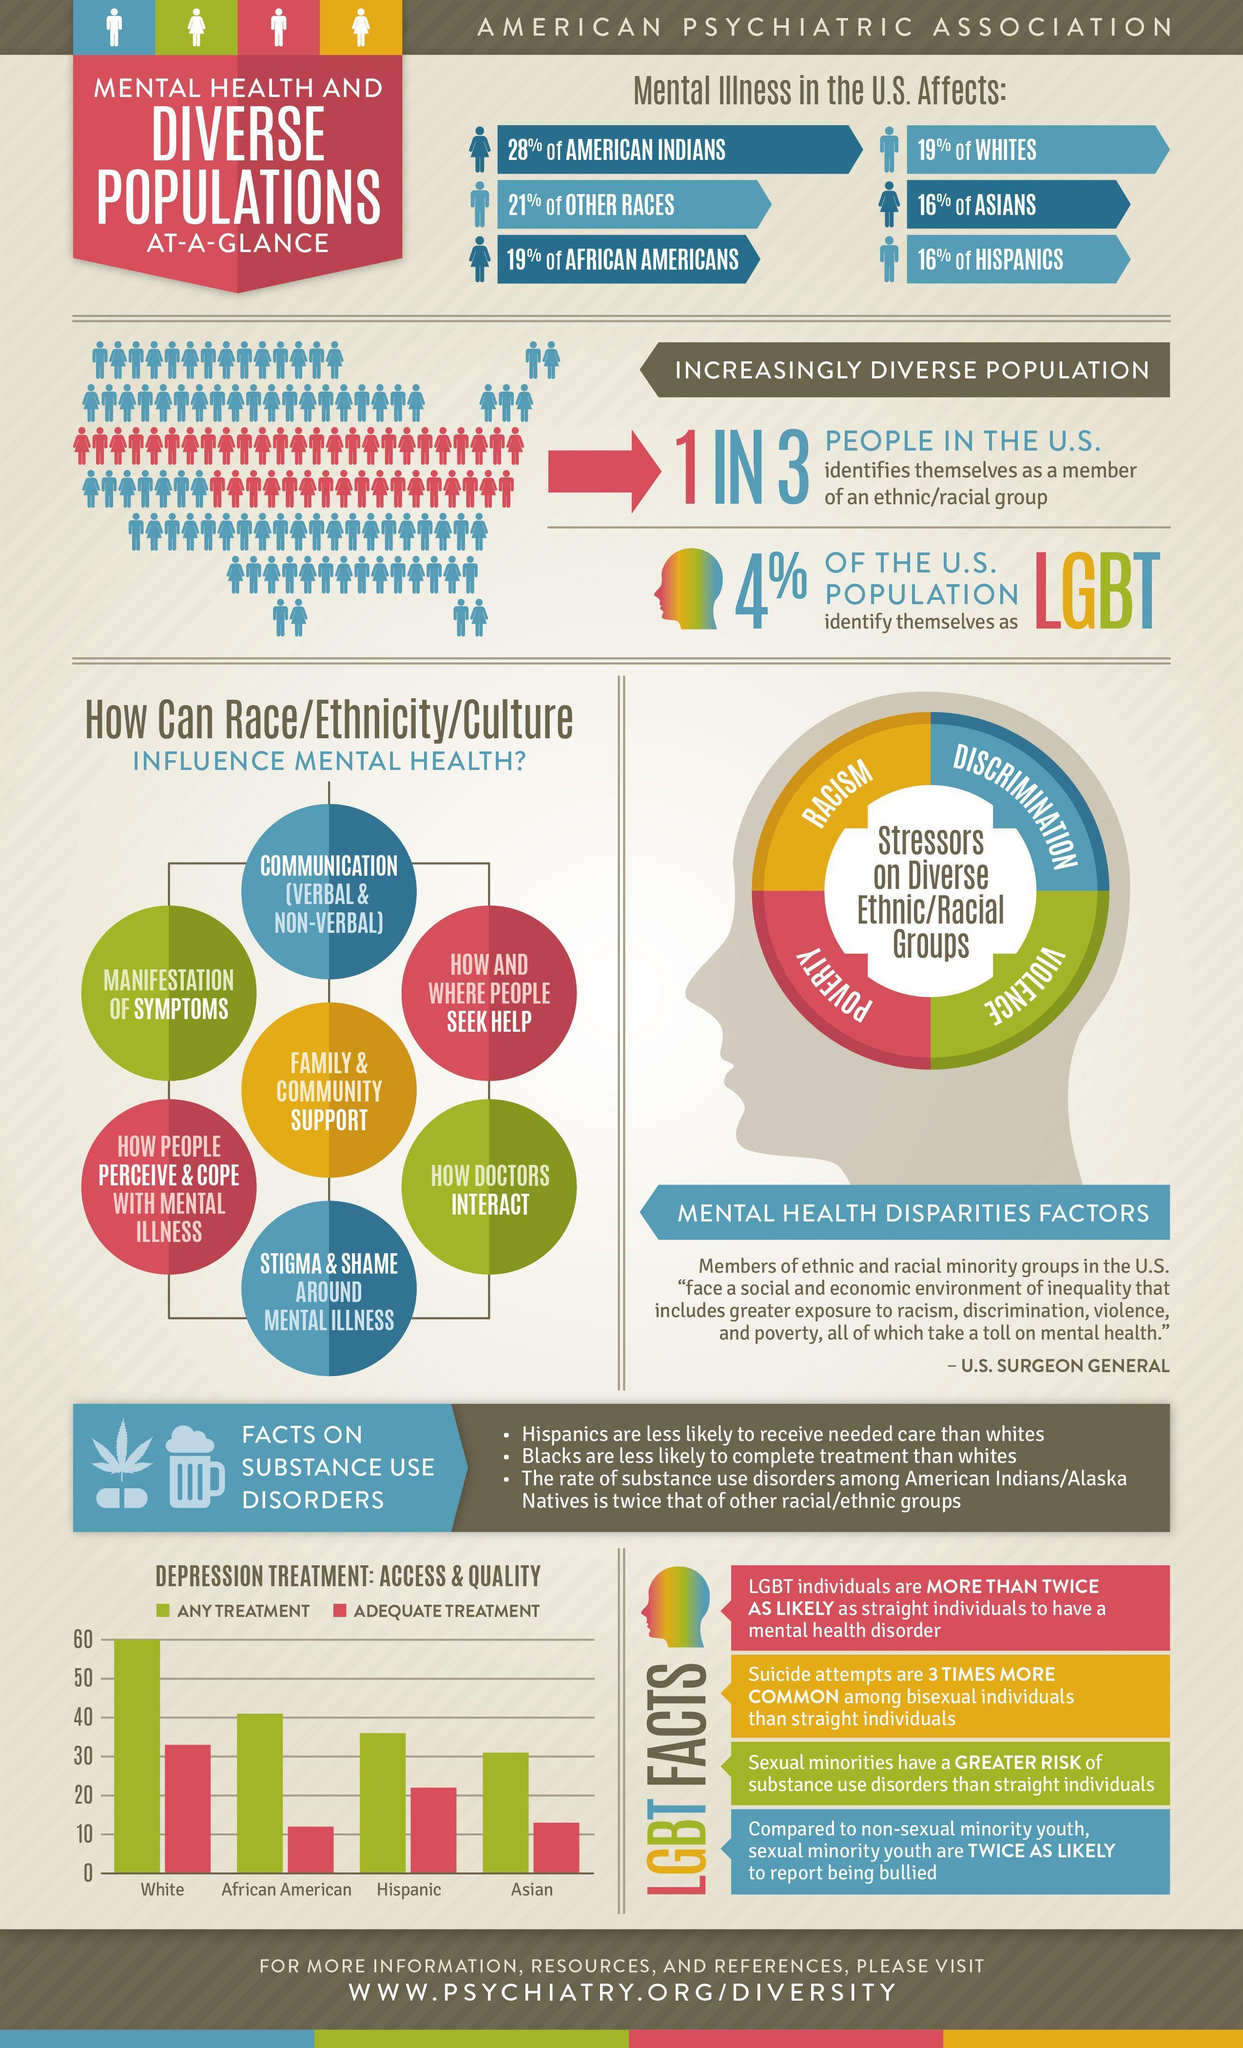In US who is affected by mental illness the most?
Answer the question with a short phrase. AMERICAN INDIANS How many points are discussed under how race/ethnicity/culture can influence mental health? 7 Which group has the best access to any treatment and adequate treatment ? White 